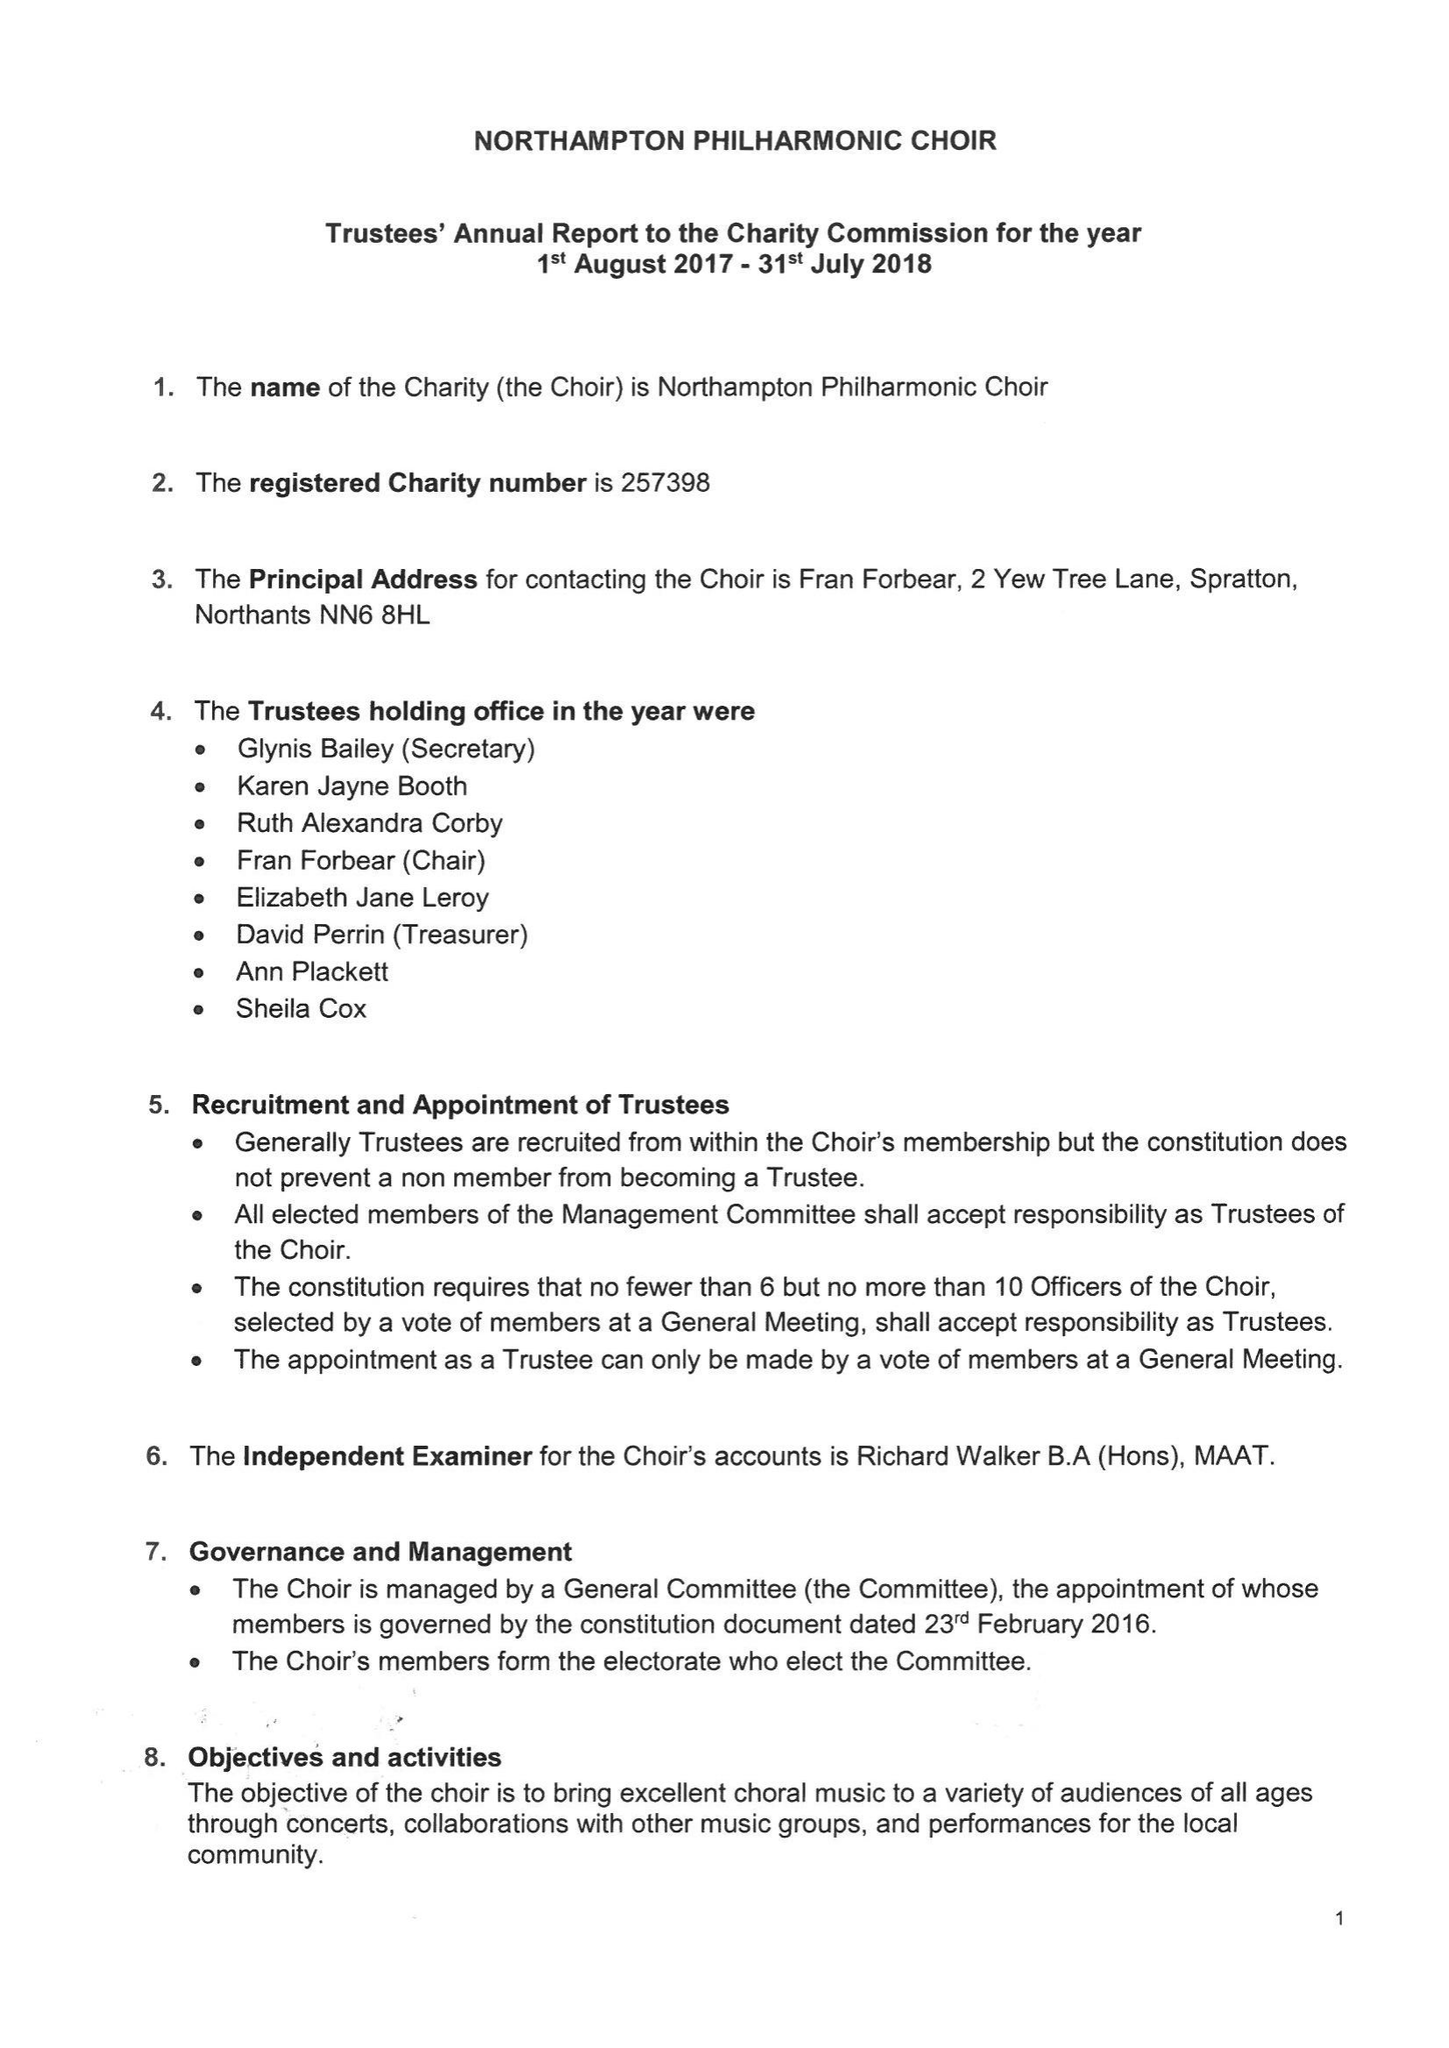What is the value for the income_annually_in_british_pounds?
Answer the question using a single word or phrase. 25790.00 